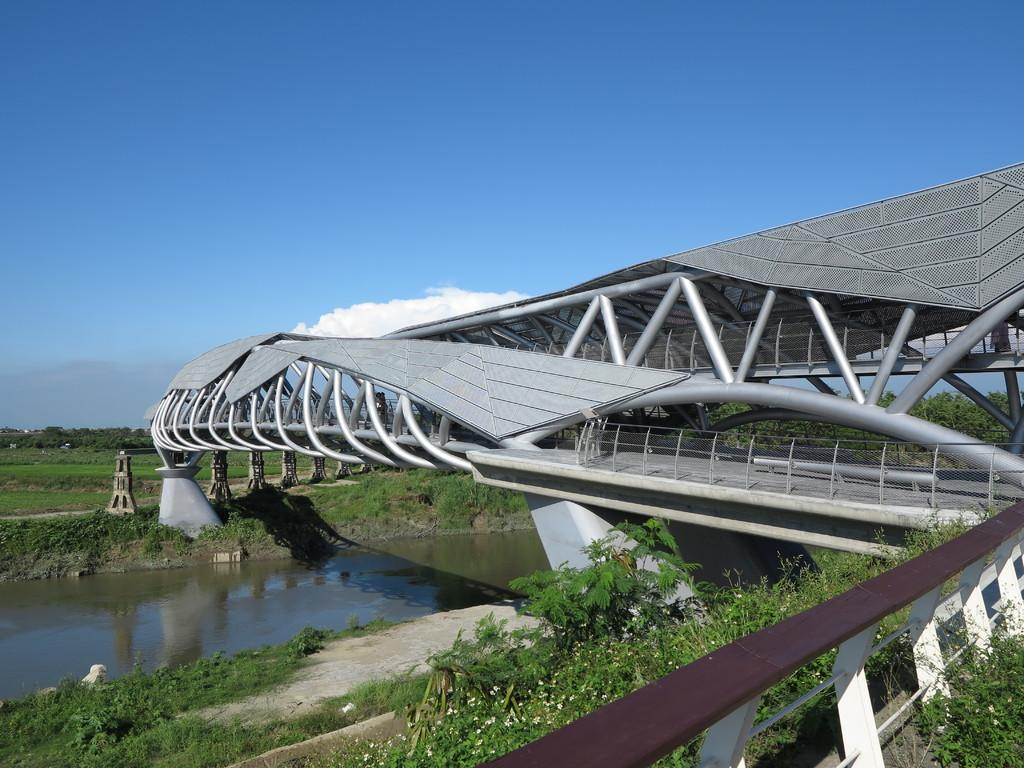What type of water feature is located on the left side of the image? There is a canal on the left side of the image. What structure can be seen on the right side of the image? There is a bridge on the right side of the image. What type of vegetation is visible in the image? There are trees visible in the image. What is visible at the top of the image? The sky is visible at the top of the image. Where is the garden located in the image? There is no garden present in the image. What type of stop sign can be seen near the bridge in the image? There is no stop sign visible in the image. 